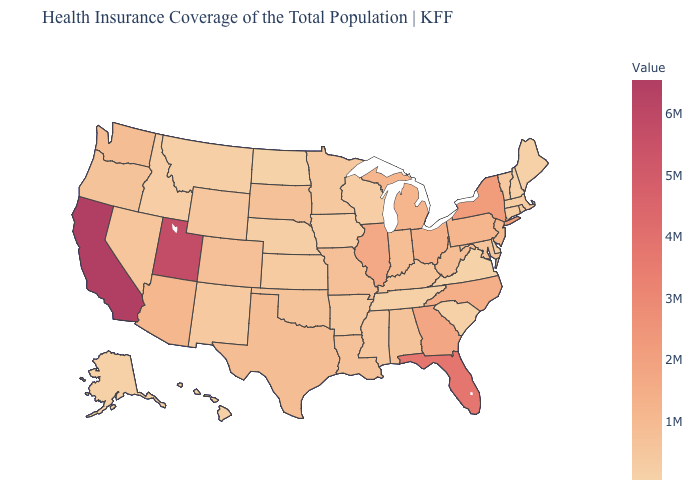Which states have the highest value in the USA?
Short answer required. California. Which states have the highest value in the USA?
Answer briefly. California. Does the map have missing data?
Write a very short answer. No. Among the states that border Oregon , does Idaho have the lowest value?
Quick response, please. Yes. Which states have the lowest value in the USA?
Write a very short answer. Virginia. Which states have the lowest value in the USA?
Concise answer only. Virginia. Does California have the lowest value in the West?
Be succinct. No. 